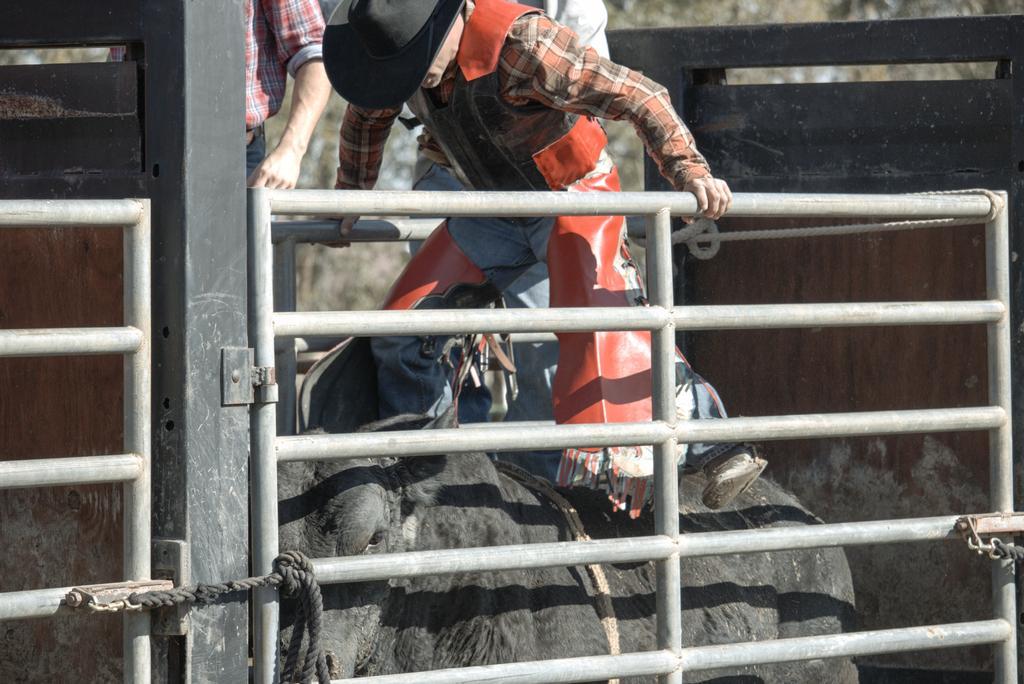Describe this image in one or two sentences. We can see rods and rope. There are people and we can see an animal. 